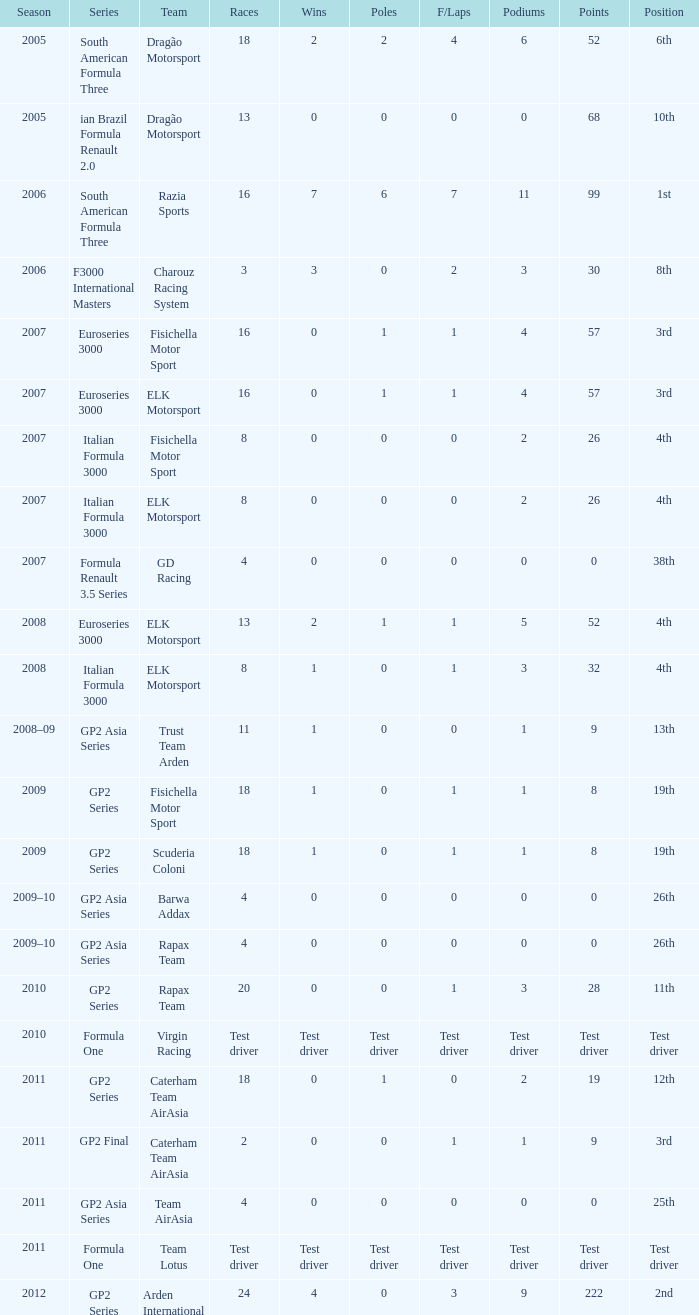What was his status in 2009 with 1 win? 19th, 19th. 